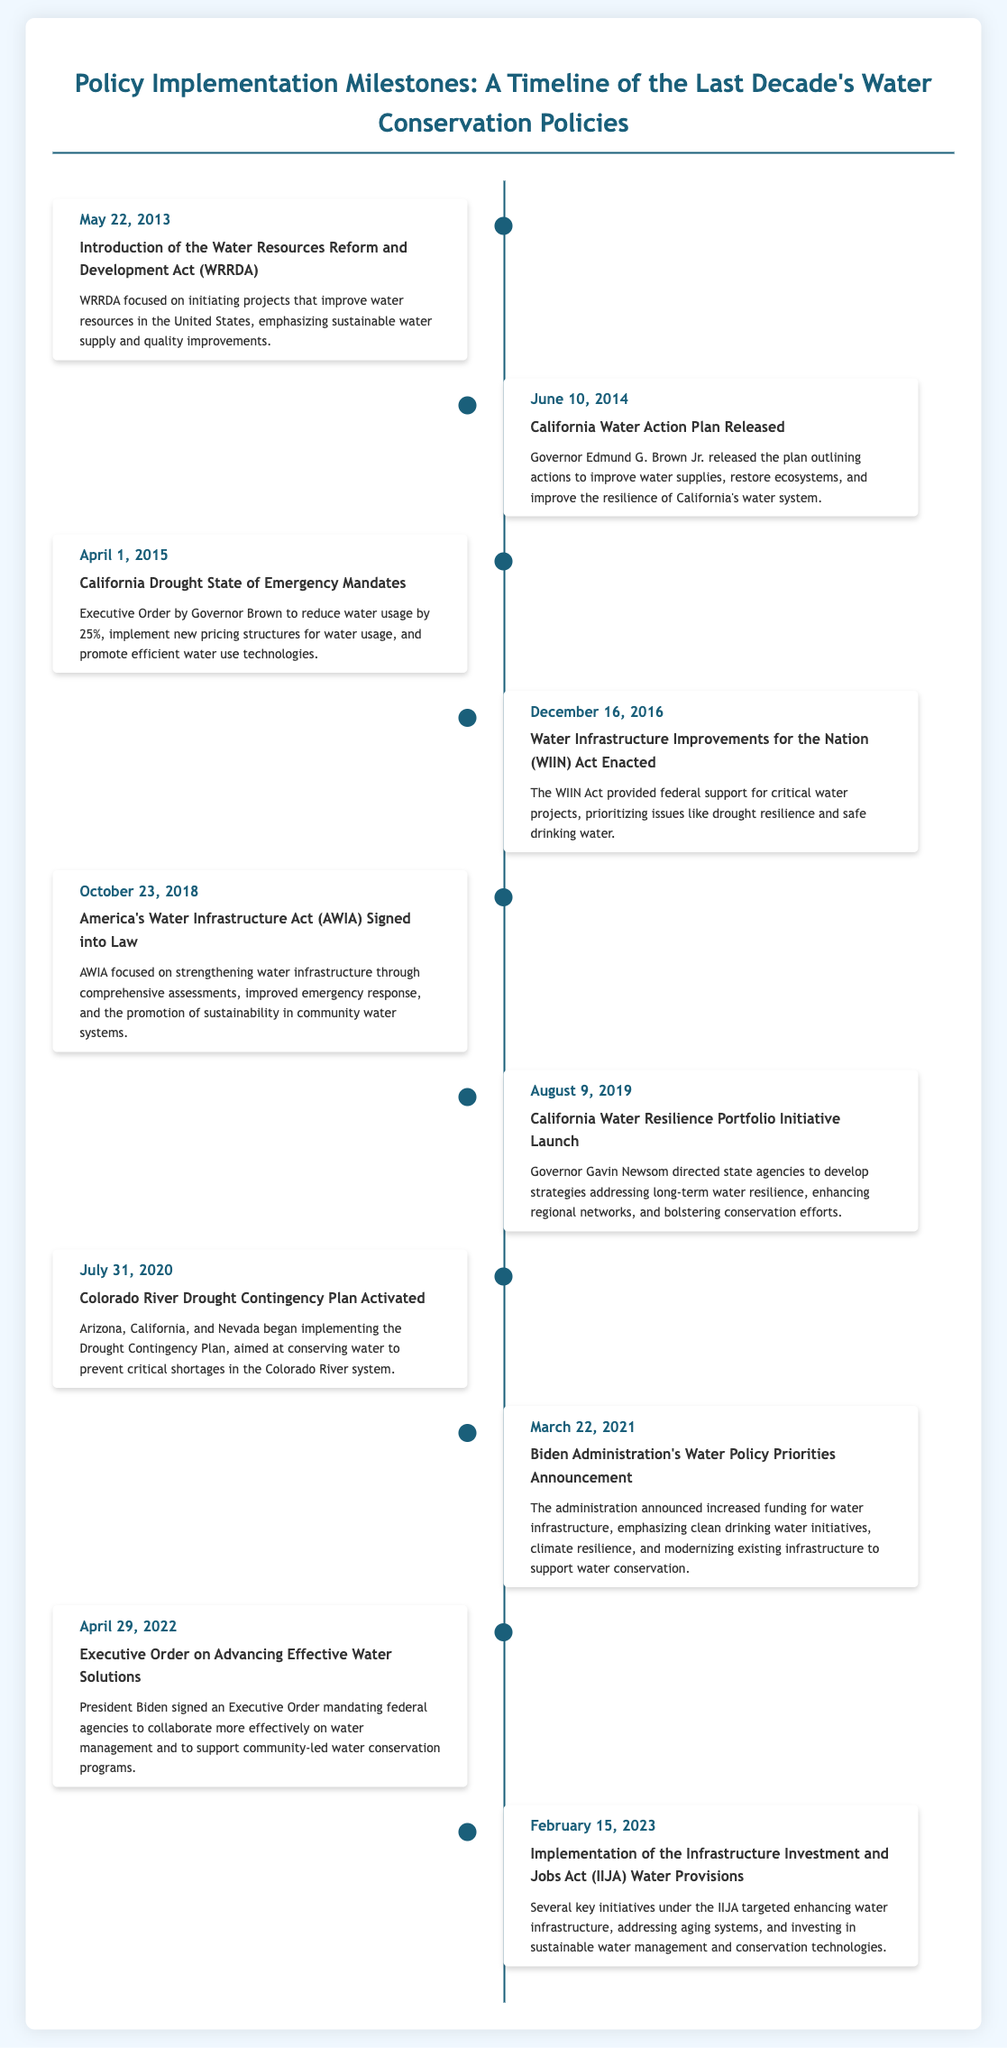what is the date of the California Drought State of Emergency Mandates? The document specifies that the California Drought State of Emergency Mandates were issued on April 1, 2015.
Answer: April 1, 2015 who released the California Water Action Plan? The California Water Action Plan was released by Governor Edmund G. Brown Jr.
Answer: Governor Edmund G. Brown Jr what act was enacted on December 16, 2016? The event occurring on December 16, 2016, refers to the Water Infrastructure Improvements for the Nation Act being enacted.
Answer: Water Infrastructure Improvements for the Nation (WIIN) Act which year did the Biden Administration announce its water policy priorities? The document indicates that the Biden Administration's water policy priorities were announced on March 22, 2021.
Answer: March 22, 2021 how many major events are documented in the timeline? The document lists a total of ten major events related to water conservation policies over the last decade.
Answer: ten what is the main focus of the Infrastructure Investment and Jobs Act's water provisions? The document highlights that the IIJA's water provisions mainly target enhancing water infrastructure and investing in sustainable water management.
Answer: enhancing water infrastructure when was the Colorado River Drought Contingency Plan activated? According to the timeline, the Colorado River Drought Contingency Plan was activated on July 31, 2020.
Answer: July 31, 2020 what significant action did President Biden take on April 29, 2022? The significant action taken by President Biden on April 29, 2022, was signing an Executive Order on Advancing Effective Water Solutions.
Answer: Executive Order on Advancing Effective Water Solutions 